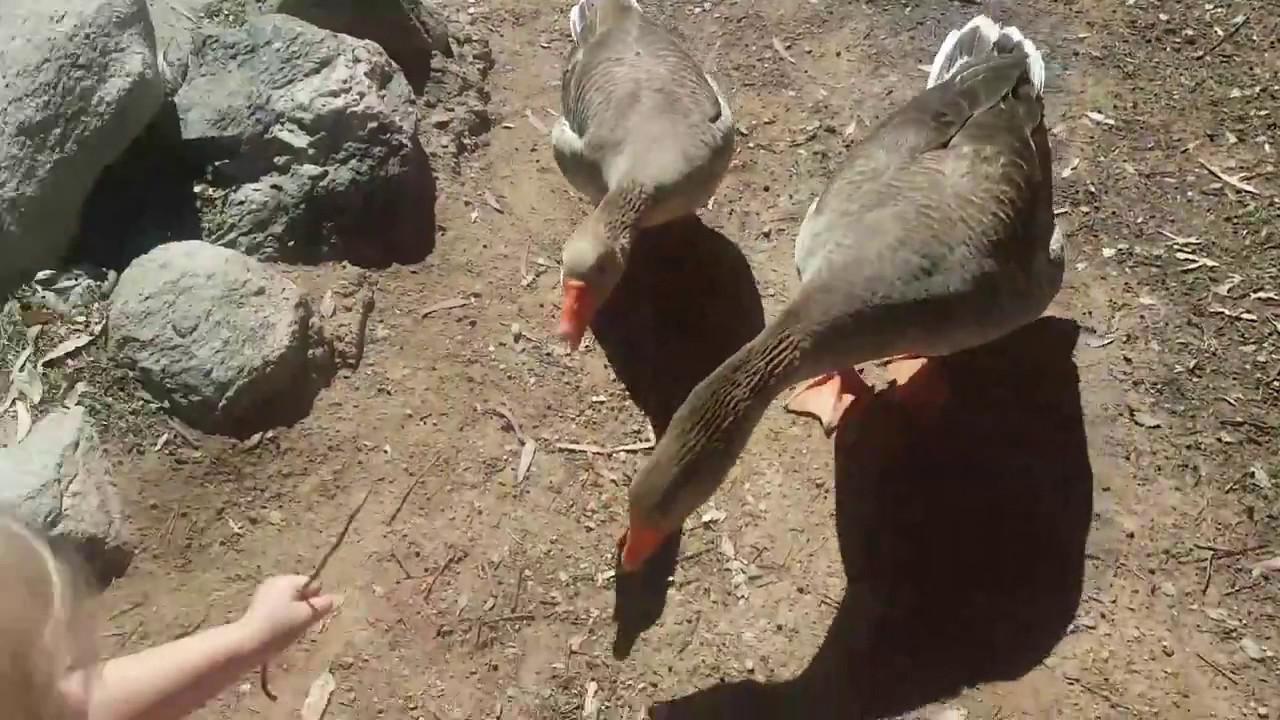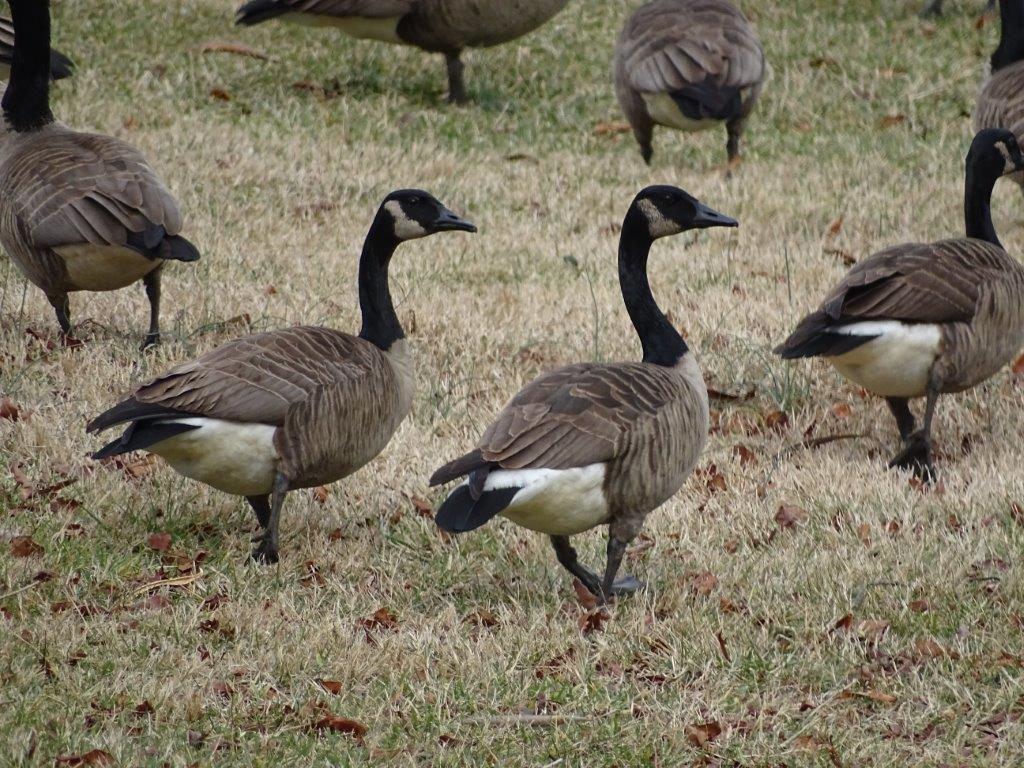The first image is the image on the left, the second image is the image on the right. Assess this claim about the two images: "None of the birds are standing on wood or snow.". Correct or not? Answer yes or no. Yes. The first image is the image on the left, the second image is the image on the right. Examine the images to the left and right. Is the description "All birds are standing, and all birds are 'real' living animals." accurate? Answer yes or no. Yes. 